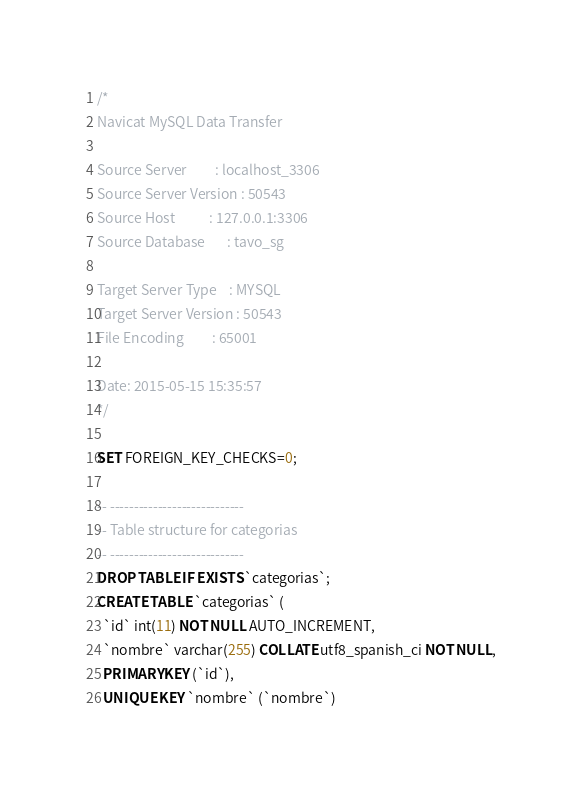<code> <loc_0><loc_0><loc_500><loc_500><_SQL_>/*
Navicat MySQL Data Transfer

Source Server         : localhost_3306
Source Server Version : 50543
Source Host           : 127.0.0.1:3306
Source Database       : tavo_sg

Target Server Type    : MYSQL
Target Server Version : 50543
File Encoding         : 65001

Date: 2015-05-15 15:35:57
*/

SET FOREIGN_KEY_CHECKS=0;

-- ----------------------------
-- Table structure for categorias
-- ----------------------------
DROP TABLE IF EXISTS `categorias`;
CREATE TABLE `categorias` (
  `id` int(11) NOT NULL AUTO_INCREMENT,
  `nombre` varchar(255) COLLATE utf8_spanish_ci NOT NULL,
  PRIMARY KEY (`id`),
  UNIQUE KEY `nombre` (`nombre`)</code> 